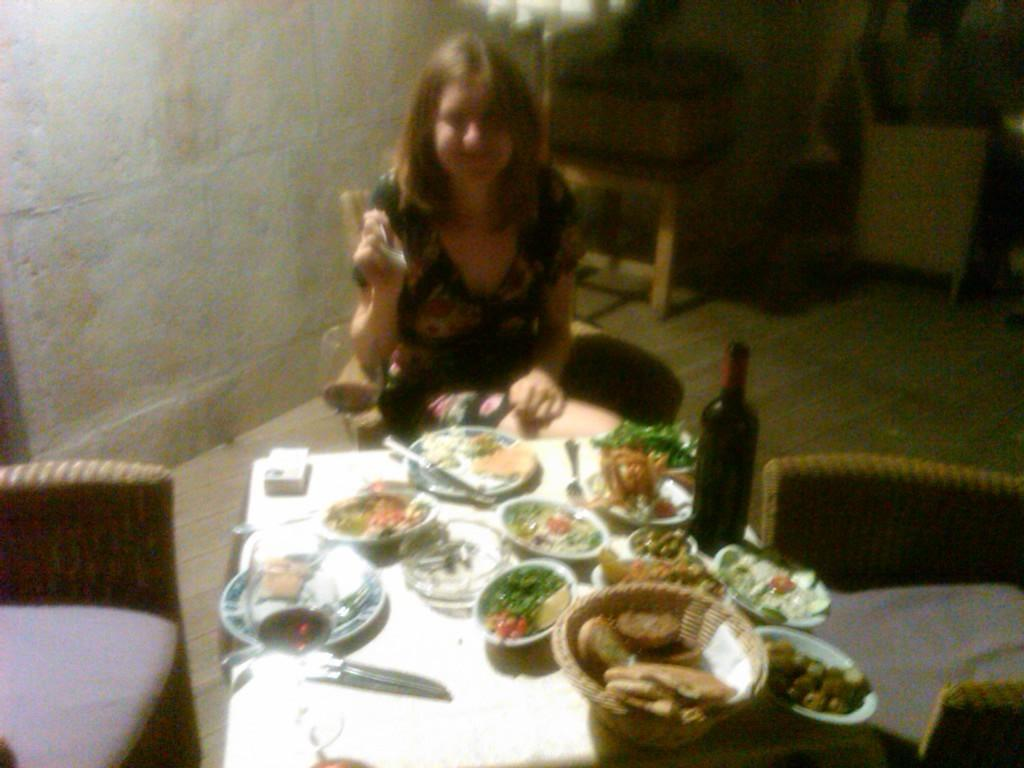What is the woman doing in the image? The woman is sitting on a chair in the image. What is the woman holding in the image? The woman is holding a spoon in the image. What is in front of the woman? There is a table in front of the woman in the image. What can be found on the table? There is a basket, bowls, plates, a bottle, and food on the table in the image. What is the woman's profit from her journey in the image? There is no mention of a journey or profit in the image. The image only shows a woman sitting on a chair, holding a spoon, and surrounded by a table with various items. 